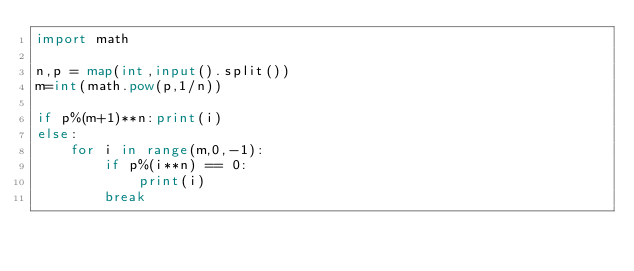Convert code to text. <code><loc_0><loc_0><loc_500><loc_500><_Python_>import math

n,p = map(int,input().split())
m=int(math.pow(p,1/n))

if p%(m+1)**n:print(i)
else:
    for i in range(m,0,-1):
        if p%(i**n) == 0:
            print(i)
        break
</code> 